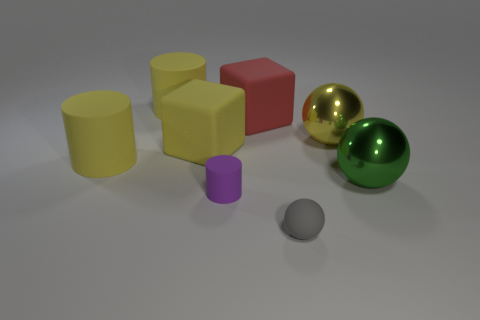What color is the small object that is the same shape as the big green object?
Ensure brevity in your answer.  Gray. There is a tiny rubber object that is in front of the tiny rubber object behind the ball to the left of the yellow ball; what is its shape?
Your answer should be compact. Sphere. Does the yellow thing to the right of the purple cylinder have the same size as the yellow cylinder in front of the big yellow rubber cube?
Provide a short and direct response. Yes. What number of yellow cylinders have the same material as the small sphere?
Make the answer very short. 2. How many gray spheres are left of the big cube behind the shiny thing behind the green metal thing?
Keep it short and to the point. 0. Does the green metallic object have the same shape as the purple thing?
Ensure brevity in your answer.  No. Are there any blue matte things of the same shape as the large red rubber thing?
Ensure brevity in your answer.  No. There is a rubber object that is the same size as the purple rubber cylinder; what is its shape?
Your response must be concise. Sphere. What material is the big cylinder that is behind the big yellow thing right of the matte sphere in front of the big yellow cube?
Give a very brief answer. Rubber. Do the purple object and the yellow metallic ball have the same size?
Your answer should be very brief. No. 